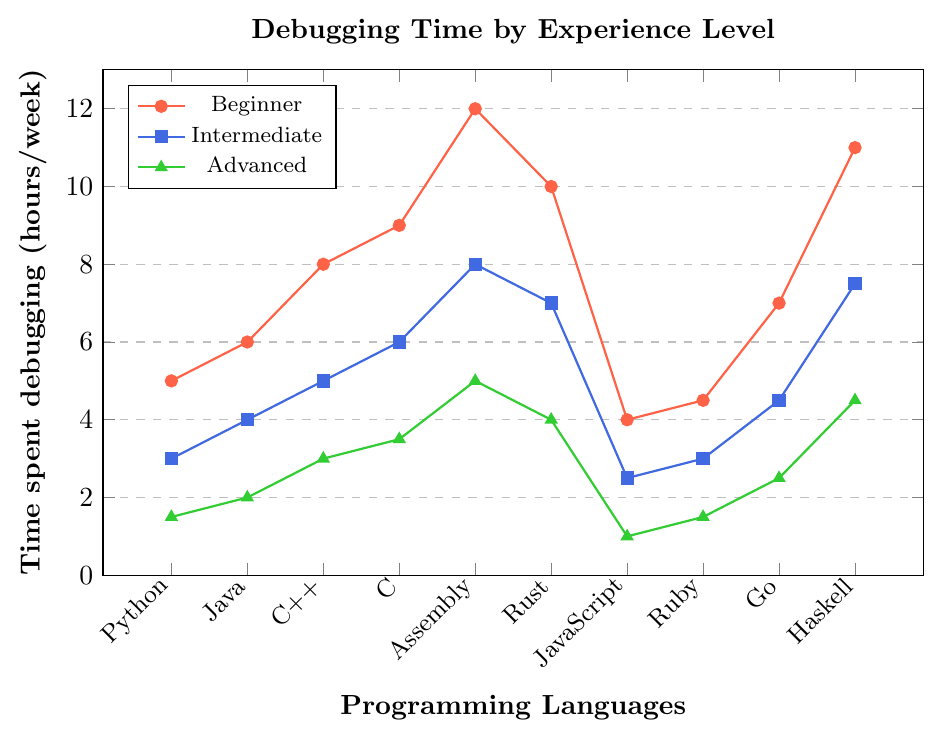What language do beginners spend the most time debugging per week? Beginners spend the most time debugging Assembly, with 12 hours per week. This is the highest value on the "Beginner" line.
Answer: Assembly What is the difference in debugging time between beginners and advanced users for Rust? Beginners spend 10 hours per week debugging in Rust, while advanced users spend 4 hours. The difference is 10 - 4 = 6 hours.
Answer: 6 hours Which experience level spends the least time debugging Python code? Looking at the Python points, advanced users spend the least time debugging Python code, which is 1.5 hours per week.
Answer: Advanced Compare the time spent debugging by intermediate users for C++ and JavaScript. Which one is higher and by how much? Intermediate users spend 5 hours per week on C++ and 2.5 hours on JavaScript. The difference is 5 - 2.5 = 2.5, with C++ being higher.
Answer: C++, 2.5 hours What is the average debugging time spent by advanced users across all languages? Sum of debugging time for advanced users across all languages: 1.5 + 2 + 3 + 3.5 + 5 + 4 + 1 + 1.5 + 2.5 + 4.5 = 28.5. There are 10 languages, so the average is 28.5 / 10 = 2.85 hours per week.
Answer: 2.85 hours Which language shows the largest decrease in debugging time from beginner to advanced? Look at the difference in debugging hours from beginners to advanced for each language: Python (5-1.5=3.5), Java (6-2=4), C++ (8-3=5), C (9-3.5=5.5), Assembly (12-5=7), Rust (10-4=6), JavaScript (4-1=3), Ruby (4.5-1.5=3), Go (7-2.5=4.5), Haskell (11-4.5=6.5). Assembly has the largest decrease of 7 hours.
Answer: Assembly How much more time do beginners spend compared to intermediate users when debugging Go? Beginners spend 7 hours per week debugging Go, while intermediate users spend 4.5 hours. The difference is 7 - 4.5 = 2.5 hours.
Answer: 2.5 hours Which language has a consistent decrease in debugging time across all experience levels without any increase? For each language, check if the debugging time decreases consistently from beginner to intermediate to advanced. Python (5, 3, 1.5), Java (6, 4, 2), C++ (8, 5, 3), C (9, 6, 3.5), Assembly (12, 8, 5), Rust (10, 7, 4), JavaScript (4, 2.5, 1), Ruby (4.5, 3, 1.5), Go (7, 4.5, 2.5), Haskell (11, 7.5, 4.5). All languages except Haskell show a consistent decrease. Therefore, Haskell does not have a consistent decrease.
Answer: All except Haskell 